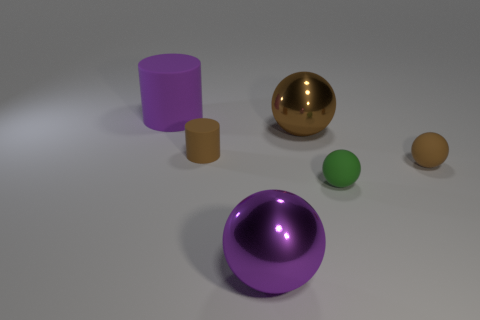Subtract all big purple balls. How many balls are left? 3 Add 2 large purple spheres. How many objects exist? 8 Subtract all purple spheres. How many spheres are left? 3 Subtract all spheres. How many objects are left? 2 Subtract 4 spheres. How many spheres are left? 0 Subtract all cyan cylinders. Subtract all green blocks. How many cylinders are left? 2 Subtract all red cylinders. How many brown balls are left? 2 Subtract all metal spheres. Subtract all brown cylinders. How many objects are left? 3 Add 6 rubber spheres. How many rubber spheres are left? 8 Add 1 big cyan blocks. How many big cyan blocks exist? 1 